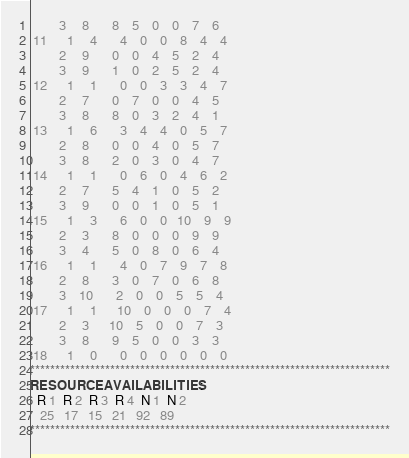<code> <loc_0><loc_0><loc_500><loc_500><_ObjectiveC_>         3     8       8    5    0    0    7    6
 11      1     4       4    0    0    8    4    4
         2     9       0    0    4    5    2    4
         3     9       1    0    2    5    2    4
 12      1     1       0    0    3    3    4    7
         2     7       0    7    0    0    4    5
         3     8       8    0    3    2    4    1
 13      1     6       3    4    4    0    5    7
         2     8       0    0    4    0    5    7
         3     8       2    0    3    0    4    7
 14      1     1       0    6    0    4    6    2
         2     7       5    4    1    0    5    2
         3     9       0    0    1    0    5    1
 15      1     3       6    0    0   10    9    9
         2     3       8    0    0    0    9    9
         3     4       5    0    8    0    6    4
 16      1     1       4    0    7    9    7    8
         2     8       3    0    7    0    6    8
         3    10       2    0    0    5    5    4
 17      1     1      10    0    0    0    7    4
         2     3      10    5    0    0    7    3
         3     8       9    5    0    0    3    3
 18      1     0       0    0    0    0    0    0
************************************************************************
RESOURCEAVAILABILITIES:
  R 1  R 2  R 3  R 4  N 1  N 2
   25   17   15   21   92   89
************************************************************************
</code> 